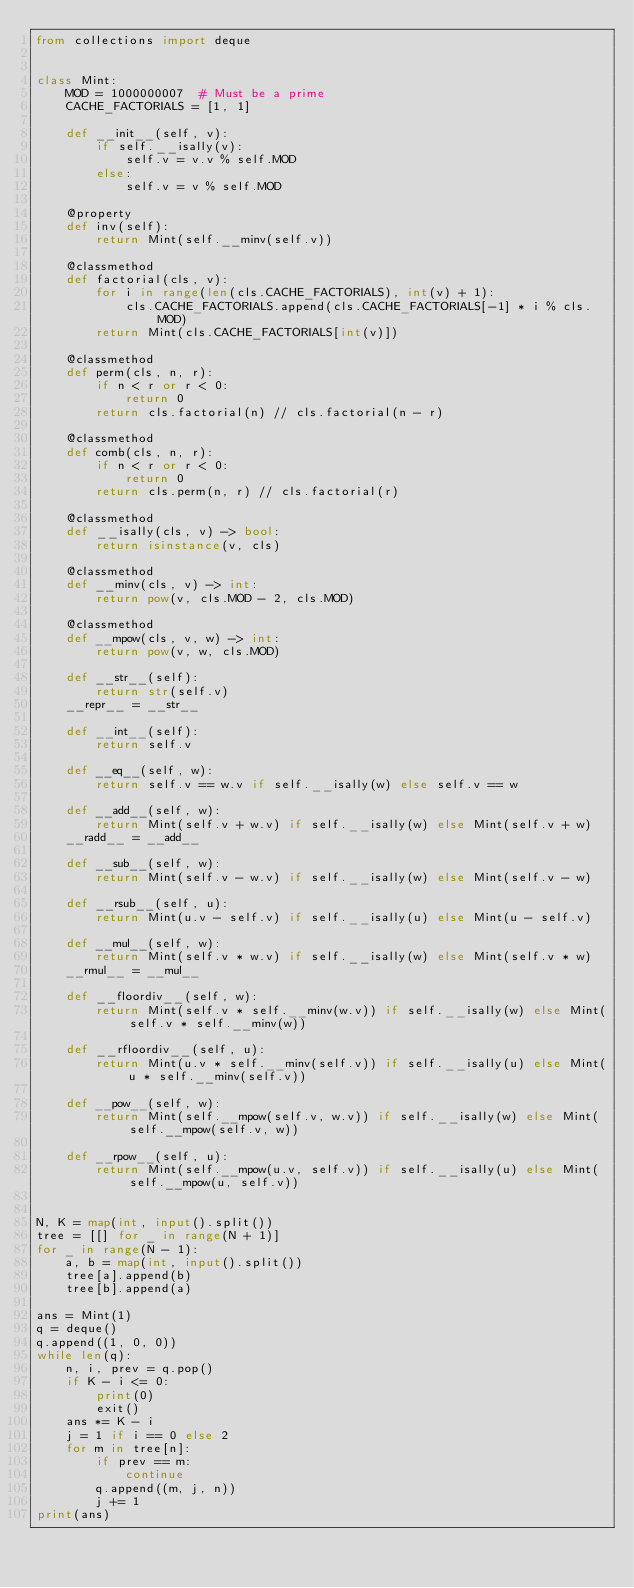Convert code to text. <code><loc_0><loc_0><loc_500><loc_500><_Python_>from collections import deque


class Mint:
    MOD = 1000000007  # Must be a prime
    CACHE_FACTORIALS = [1, 1]

    def __init__(self, v):
        if self.__isally(v):
            self.v = v.v % self.MOD
        else:
            self.v = v % self.MOD

    @property
    def inv(self):
        return Mint(self.__minv(self.v))

    @classmethod
    def factorial(cls, v):
        for i in range(len(cls.CACHE_FACTORIALS), int(v) + 1):
            cls.CACHE_FACTORIALS.append(cls.CACHE_FACTORIALS[-1] * i % cls.MOD)
        return Mint(cls.CACHE_FACTORIALS[int(v)])

    @classmethod
    def perm(cls, n, r):
        if n < r or r < 0:
            return 0
        return cls.factorial(n) // cls.factorial(n - r)

    @classmethod
    def comb(cls, n, r):
        if n < r or r < 0:
            return 0
        return cls.perm(n, r) // cls.factorial(r)

    @classmethod
    def __isally(cls, v) -> bool:
        return isinstance(v, cls)

    @classmethod
    def __minv(cls, v) -> int:
        return pow(v, cls.MOD - 2, cls.MOD)

    @classmethod
    def __mpow(cls, v, w) -> int:
        return pow(v, w, cls.MOD)

    def __str__(self):
        return str(self.v)
    __repr__ = __str__

    def __int__(self):
        return self.v

    def __eq__(self, w):
        return self.v == w.v if self.__isally(w) else self.v == w

    def __add__(self, w):
        return Mint(self.v + w.v) if self.__isally(w) else Mint(self.v + w)
    __radd__ = __add__

    def __sub__(self, w):
        return Mint(self.v - w.v) if self.__isally(w) else Mint(self.v - w)

    def __rsub__(self, u):
        return Mint(u.v - self.v) if self.__isally(u) else Mint(u - self.v)

    def __mul__(self, w):
        return Mint(self.v * w.v) if self.__isally(w) else Mint(self.v * w)
    __rmul__ = __mul__

    def __floordiv__(self, w):
        return Mint(self.v * self.__minv(w.v)) if self.__isally(w) else Mint(self.v * self.__minv(w))

    def __rfloordiv__(self, u):
        return Mint(u.v * self.__minv(self.v)) if self.__isally(u) else Mint(u * self.__minv(self.v))

    def __pow__(self, w):
        return Mint(self.__mpow(self.v, w.v)) if self.__isally(w) else Mint(self.__mpow(self.v, w))

    def __rpow__(self, u):
        return Mint(self.__mpow(u.v, self.v)) if self.__isally(u) else Mint(self.__mpow(u, self.v))


N, K = map(int, input().split())
tree = [[] for _ in range(N + 1)]
for _ in range(N - 1):
    a, b = map(int, input().split())
    tree[a].append(b)
    tree[b].append(a)

ans = Mint(1)
q = deque()
q.append((1, 0, 0))
while len(q):
    n, i, prev = q.pop()
    if K - i <= 0:
        print(0)
        exit()
    ans *= K - i
    j = 1 if i == 0 else 2
    for m in tree[n]:
        if prev == m:
            continue
        q.append((m, j, n))
        j += 1
print(ans)
</code> 